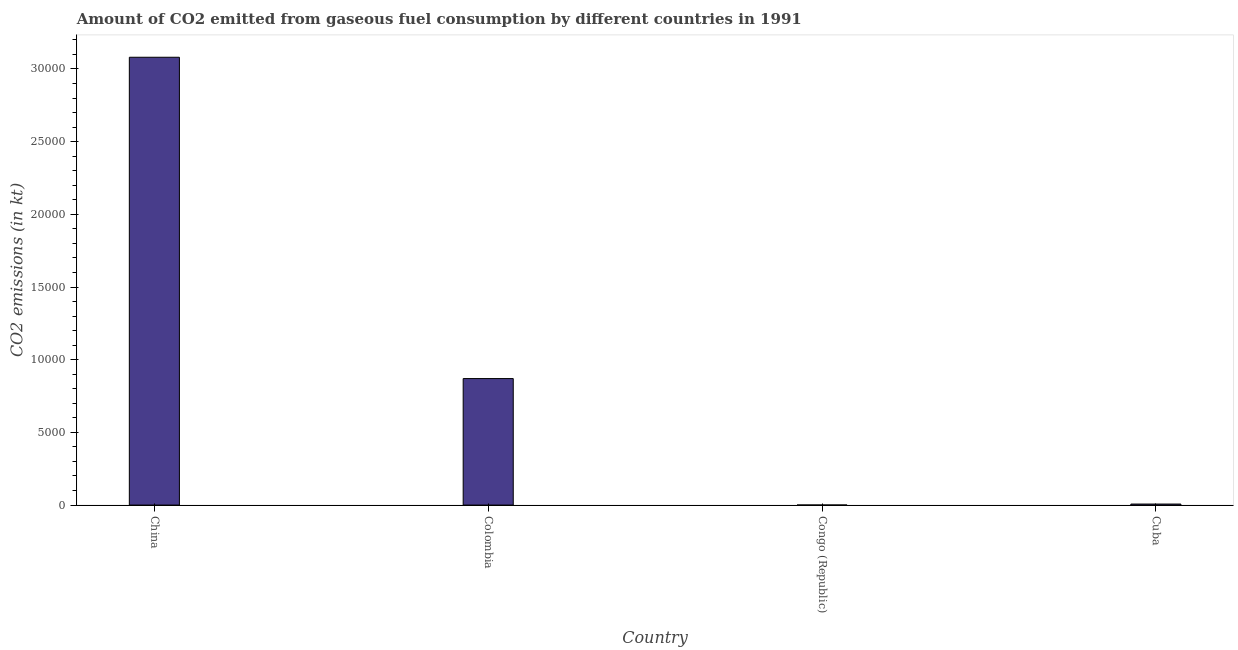Does the graph contain grids?
Your answer should be very brief. No. What is the title of the graph?
Provide a succinct answer. Amount of CO2 emitted from gaseous fuel consumption by different countries in 1991. What is the label or title of the X-axis?
Give a very brief answer. Country. What is the label or title of the Y-axis?
Your answer should be compact. CO2 emissions (in kt). What is the co2 emissions from gaseous fuel consumption in Congo (Republic)?
Your answer should be compact. 3.67. Across all countries, what is the maximum co2 emissions from gaseous fuel consumption?
Your response must be concise. 3.08e+04. Across all countries, what is the minimum co2 emissions from gaseous fuel consumption?
Give a very brief answer. 3.67. In which country was the co2 emissions from gaseous fuel consumption maximum?
Give a very brief answer. China. In which country was the co2 emissions from gaseous fuel consumption minimum?
Make the answer very short. Congo (Republic). What is the sum of the co2 emissions from gaseous fuel consumption?
Make the answer very short. 3.96e+04. What is the difference between the co2 emissions from gaseous fuel consumption in China and Congo (Republic)?
Keep it short and to the point. 3.08e+04. What is the average co2 emissions from gaseous fuel consumption per country?
Give a very brief answer. 9894.48. What is the median co2 emissions from gaseous fuel consumption?
Offer a terse response. 4385.73. In how many countries, is the co2 emissions from gaseous fuel consumption greater than 25000 kt?
Provide a succinct answer. 1. What is the ratio of the co2 emissions from gaseous fuel consumption in Congo (Republic) to that in Cuba?
Your answer should be very brief. 0.05. Is the co2 emissions from gaseous fuel consumption in Congo (Republic) less than that in Cuba?
Ensure brevity in your answer.  Yes. Is the difference between the co2 emissions from gaseous fuel consumption in China and Colombia greater than the difference between any two countries?
Your response must be concise. No. What is the difference between the highest and the second highest co2 emissions from gaseous fuel consumption?
Your response must be concise. 2.21e+04. What is the difference between the highest and the lowest co2 emissions from gaseous fuel consumption?
Ensure brevity in your answer.  3.08e+04. What is the difference between two consecutive major ticks on the Y-axis?
Your answer should be very brief. 5000. What is the CO2 emissions (in kt) in China?
Offer a terse response. 3.08e+04. What is the CO2 emissions (in kt) of Colombia?
Keep it short and to the point. 8701.79. What is the CO2 emissions (in kt) of Congo (Republic)?
Provide a succinct answer. 3.67. What is the CO2 emissions (in kt) in Cuba?
Your answer should be very brief. 69.67. What is the difference between the CO2 emissions (in kt) in China and Colombia?
Provide a short and direct response. 2.21e+04. What is the difference between the CO2 emissions (in kt) in China and Congo (Republic)?
Ensure brevity in your answer.  3.08e+04. What is the difference between the CO2 emissions (in kt) in China and Cuba?
Keep it short and to the point. 3.07e+04. What is the difference between the CO2 emissions (in kt) in Colombia and Congo (Republic)?
Provide a short and direct response. 8698.12. What is the difference between the CO2 emissions (in kt) in Colombia and Cuba?
Your answer should be compact. 8632.12. What is the difference between the CO2 emissions (in kt) in Congo (Republic) and Cuba?
Your answer should be compact. -66.01. What is the ratio of the CO2 emissions (in kt) in China to that in Colombia?
Your answer should be compact. 3.54. What is the ratio of the CO2 emissions (in kt) in China to that in Congo (Republic)?
Ensure brevity in your answer.  8400. What is the ratio of the CO2 emissions (in kt) in China to that in Cuba?
Your answer should be compact. 442.11. What is the ratio of the CO2 emissions (in kt) in Colombia to that in Congo (Republic)?
Your response must be concise. 2373. What is the ratio of the CO2 emissions (in kt) in Colombia to that in Cuba?
Provide a short and direct response. 124.89. What is the ratio of the CO2 emissions (in kt) in Congo (Republic) to that in Cuba?
Offer a very short reply. 0.05. 